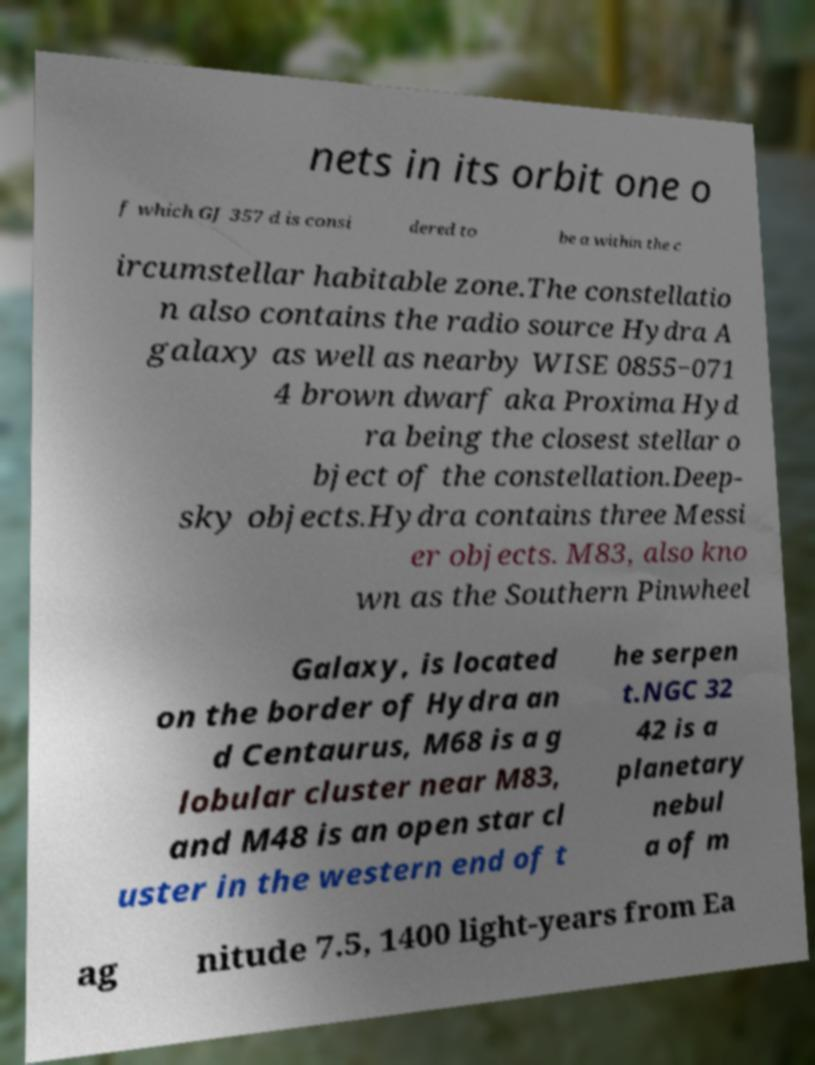Please read and relay the text visible in this image. What does it say? nets in its orbit one o f which GJ 357 d is consi dered to be a within the c ircumstellar habitable zone.The constellatio n also contains the radio source Hydra A galaxy as well as nearby WISE 0855−071 4 brown dwarf aka Proxima Hyd ra being the closest stellar o bject of the constellation.Deep- sky objects.Hydra contains three Messi er objects. M83, also kno wn as the Southern Pinwheel Galaxy, is located on the border of Hydra an d Centaurus, M68 is a g lobular cluster near M83, and M48 is an open star cl uster in the western end of t he serpen t.NGC 32 42 is a planetary nebul a of m ag nitude 7.5, 1400 light-years from Ea 